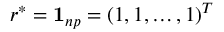Convert formula to latex. <formula><loc_0><loc_0><loc_500><loc_500>r ^ { * } = 1 _ { n p } = ( 1 , 1 , \dots , 1 ) ^ { T }</formula> 